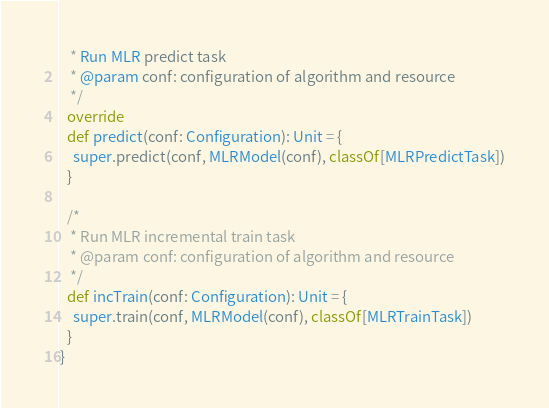Convert code to text. <code><loc_0><loc_0><loc_500><loc_500><_Scala_>   * Run MLR predict task
   * @param conf: configuration of algorithm and resource
   */
  override
  def predict(conf: Configuration): Unit = {
    super.predict(conf, MLRModel(conf), classOf[MLRPredictTask])
  }

  /*
   * Run MLR incremental train task
   * @param conf: configuration of algorithm and resource
   */
  def incTrain(conf: Configuration): Unit = {
    super.train(conf, MLRModel(conf), classOf[MLRTrainTask])
  }
}

</code> 